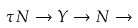<formula> <loc_0><loc_0><loc_500><loc_500>\tau N \rightarrow Y \rightarrow N \rightarrow</formula> 